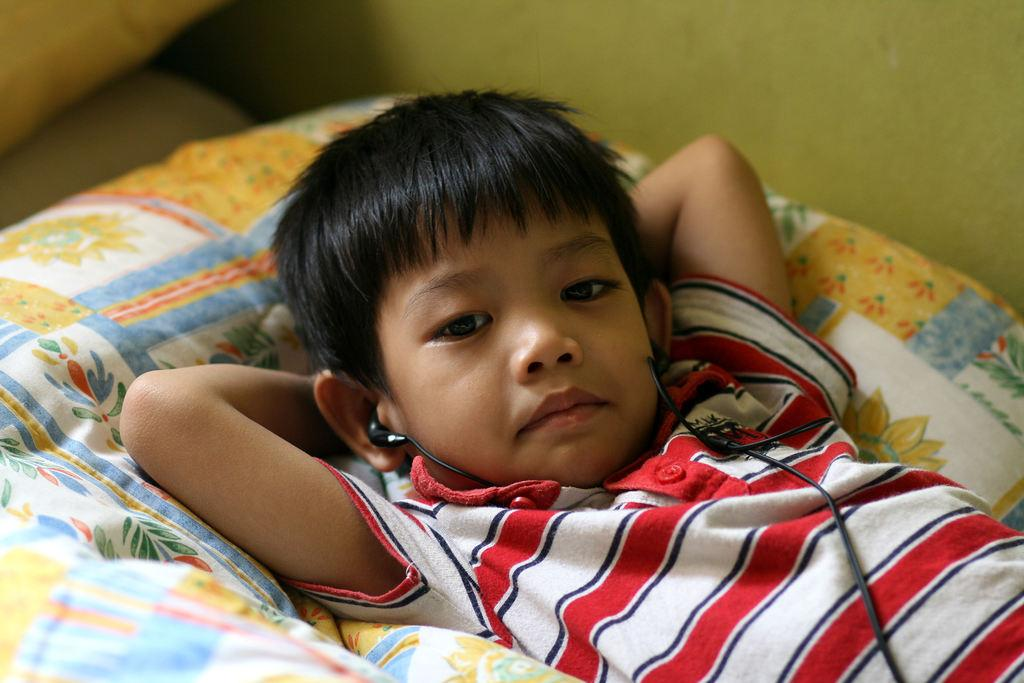Who is the main subject in the image? There is a boy in the image. What is the boy wearing on his head? The boy is wearing headsets. What is the boy doing in the image? The boy is lying on an object. What can be seen in the background of the image? There is a wall visible in the image. What colors are present in the objects in the image? There are yellow and white color objects in the image. What type of wrench is the boy using to fix the brick in the image? There is no wrench or brick present in the image. How does the boy interact with the ground in the image? The boy is lying on an object, not interacting with the ground in the image. 